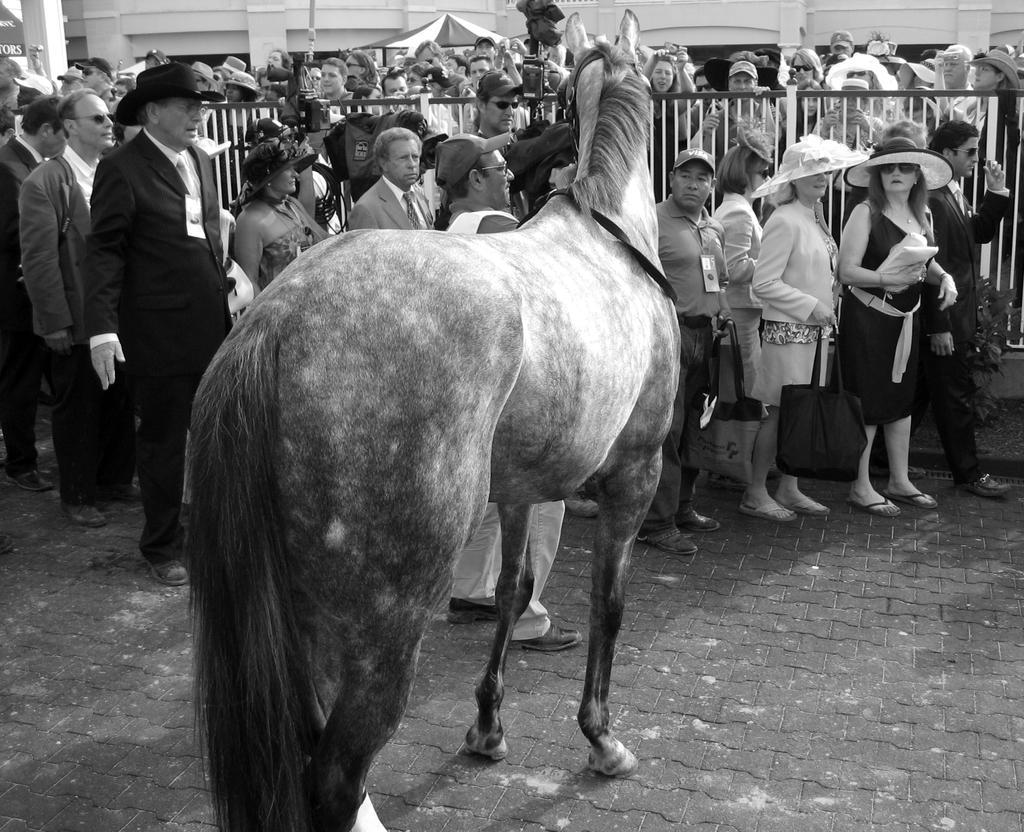How would you summarize this image in a sentence or two? This picture is clicked outside. In the center there is a horse standing on the ground. Behind the horse there are group of persons standing. In the background we can see an Umbrella and a group of people standing and looking at a horse and a Building. 